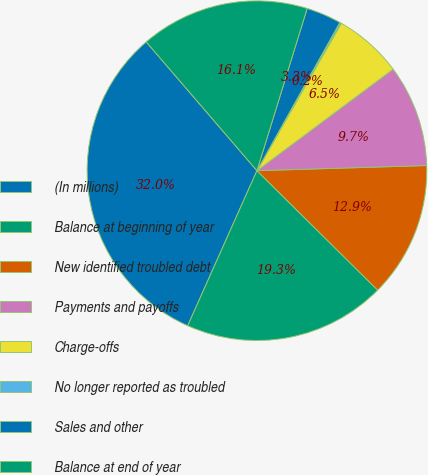Convert chart to OTSL. <chart><loc_0><loc_0><loc_500><loc_500><pie_chart><fcel>(In millions)<fcel>Balance at beginning of year<fcel>New identified troubled debt<fcel>Payments and payoffs<fcel>Charge-offs<fcel>No longer reported as troubled<fcel>Sales and other<fcel>Balance at end of year<nl><fcel>32.01%<fcel>19.27%<fcel>12.9%<fcel>9.71%<fcel>6.53%<fcel>0.16%<fcel>3.34%<fcel>16.08%<nl></chart> 